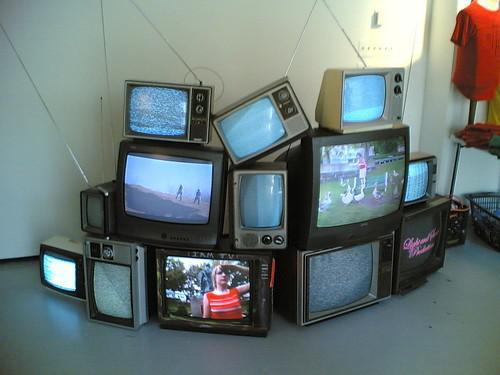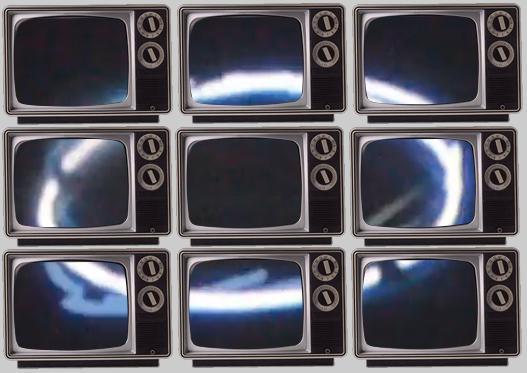The first image is the image on the left, the second image is the image on the right. Assess this claim about the two images: "The televisions in the left image appear to be powered on.". Correct or not? Answer yes or no. Yes. 